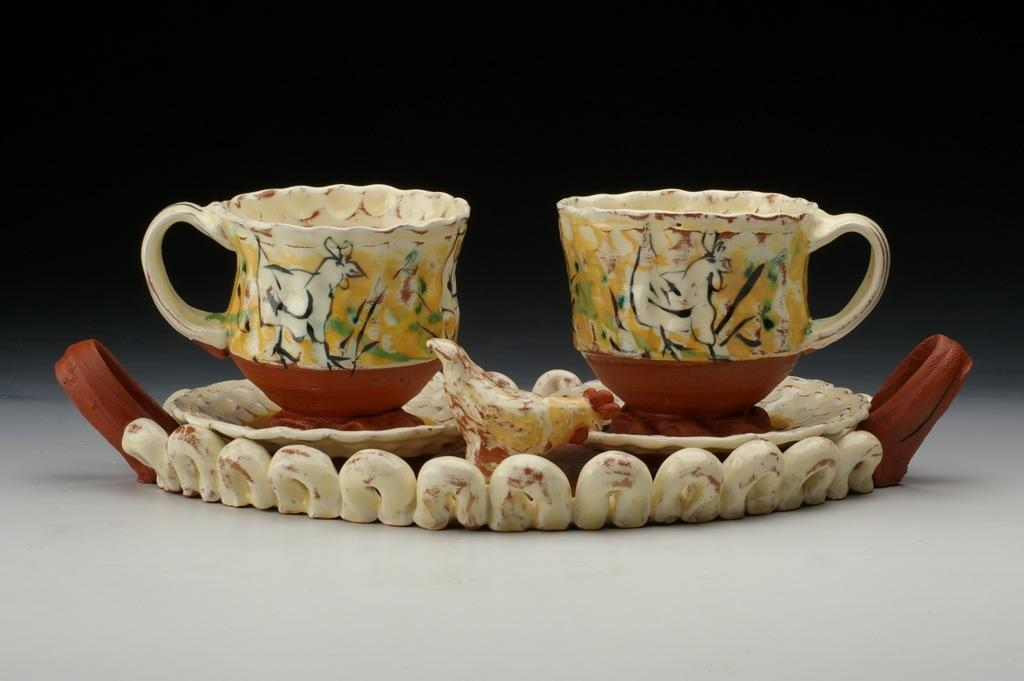What type of dishware is visible in the image? There are cups and saucers in the image. What surface are the cups and saucers placed on? The cups and saucers are on a white surface. What type of weather is depicted in the image with the cups and saucers? There is no weather depicted in the image; it only shows cups and saucers on a white surface. Can you tell me how many horses are present in the image? There are no horses present in the image; it only shows cups and saucers on a white surface. 